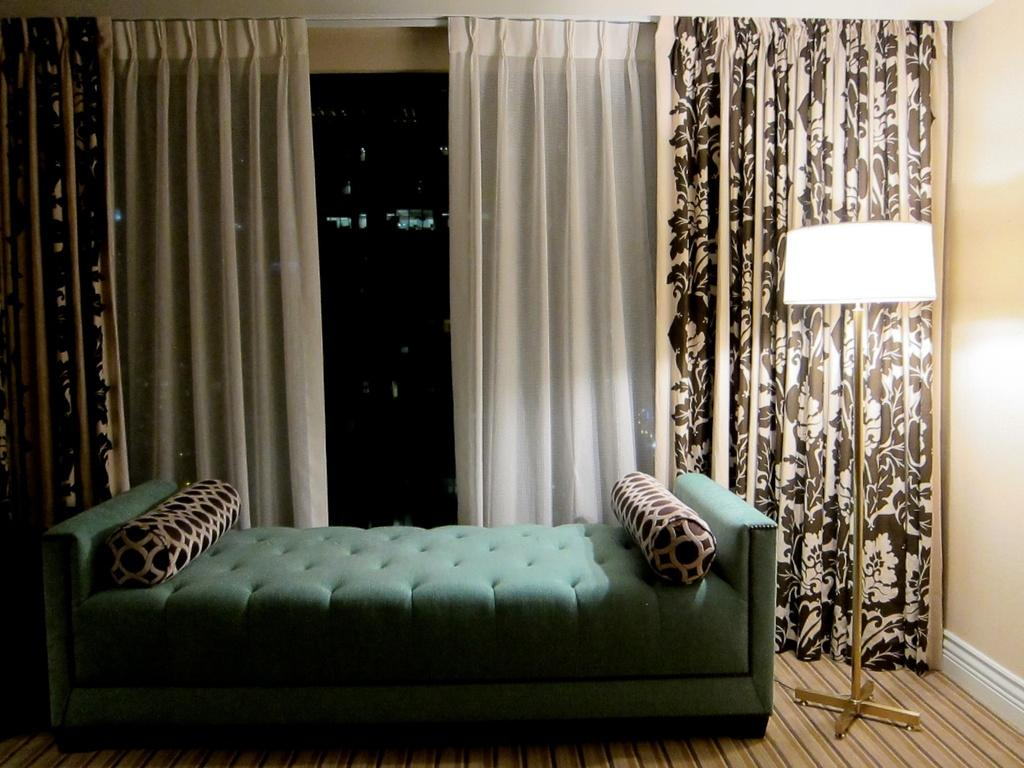What type of furniture is present in the image? There is a bed in the image. What is placed on the bed? There are pillows on the bed. What can be seen in the background of the image? There is a window in the background of the image. What is associated with the window? There are curtains associated with the window. What is located on the right side of the image? There is a lamp on the right side of the image. What is visible at the bottom of the image? There is a floor visible at the bottom of the image. How many chickens are visible in the image? There are no chickens present in the image. What type of tub is located near the bed in the image? There is no tub present in the image. 